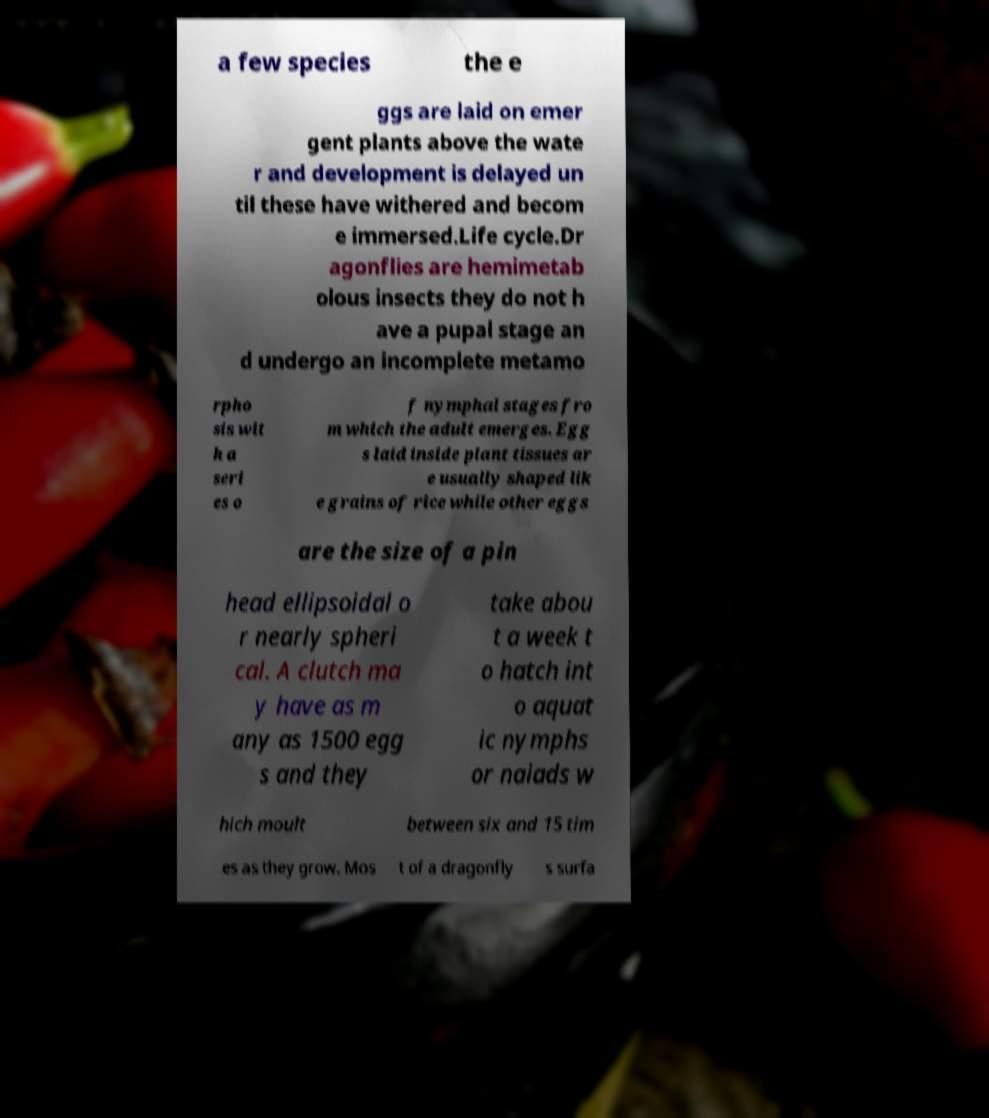Can you read and provide the text displayed in the image?This photo seems to have some interesting text. Can you extract and type it out for me? a few species the e ggs are laid on emer gent plants above the wate r and development is delayed un til these have withered and becom e immersed.Life cycle.Dr agonflies are hemimetab olous insects they do not h ave a pupal stage an d undergo an incomplete metamo rpho sis wit h a seri es o f nymphal stages fro m which the adult emerges. Egg s laid inside plant tissues ar e usually shaped lik e grains of rice while other eggs are the size of a pin head ellipsoidal o r nearly spheri cal. A clutch ma y have as m any as 1500 egg s and they take abou t a week t o hatch int o aquat ic nymphs or naiads w hich moult between six and 15 tim es as they grow. Mos t of a dragonfly s surfa 